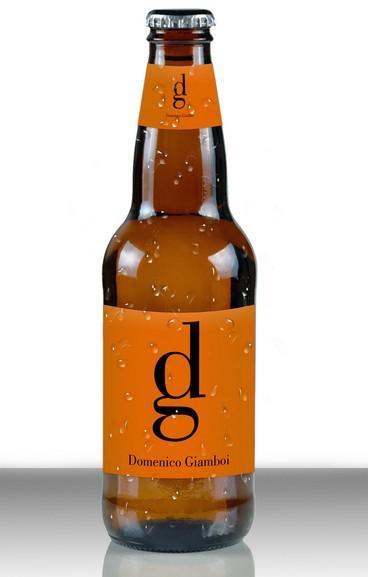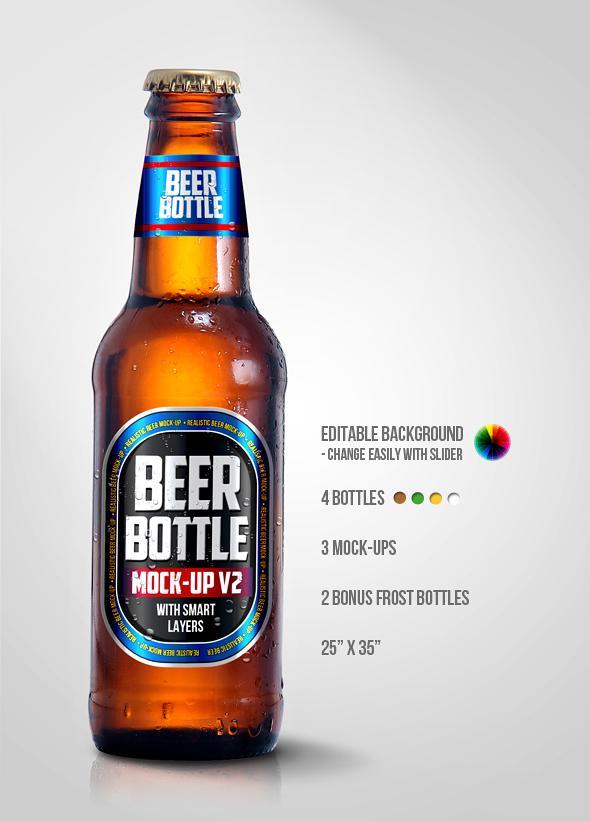The first image is the image on the left, the second image is the image on the right. Given the left and right images, does the statement "At least two beer bottles have labels on body and neck of the bottle, and exactly one bottle has just a body label." hold true? Answer yes or no. No. The first image is the image on the left, the second image is the image on the right. Considering the images on both sides, is "There are two glass beer bottles" valid? Answer yes or no. Yes. 